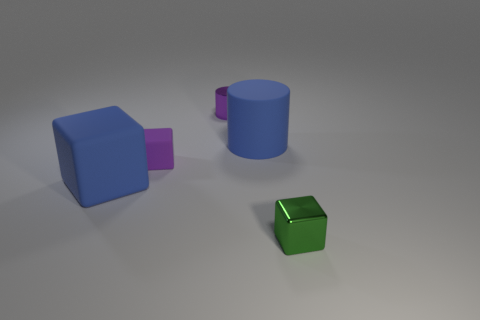Add 2 small green cubes. How many objects exist? 7 Subtract all shiny cubes. How many cubes are left? 2 Subtract 1 cubes. How many cubes are left? 2 Subtract all purple cubes. How many cubes are left? 2 Subtract all cylinders. How many objects are left? 3 Add 3 blue matte objects. How many blue matte objects are left? 5 Add 1 tiny green metal blocks. How many tiny green metal blocks exist? 2 Subtract 1 purple cubes. How many objects are left? 4 Subtract all blue blocks. Subtract all purple balls. How many blocks are left? 2 Subtract all brown balls. How many gray cubes are left? 0 